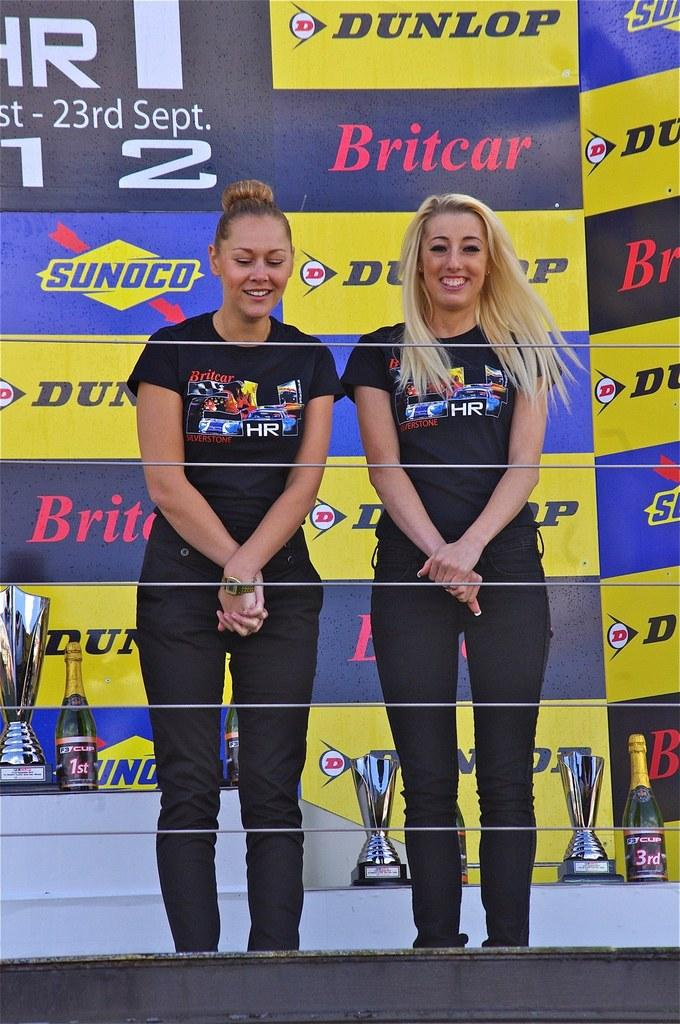<image>
Relay a brief, clear account of the picture shown. Two young women pose in front of Dunlop and Sunoco logos. 